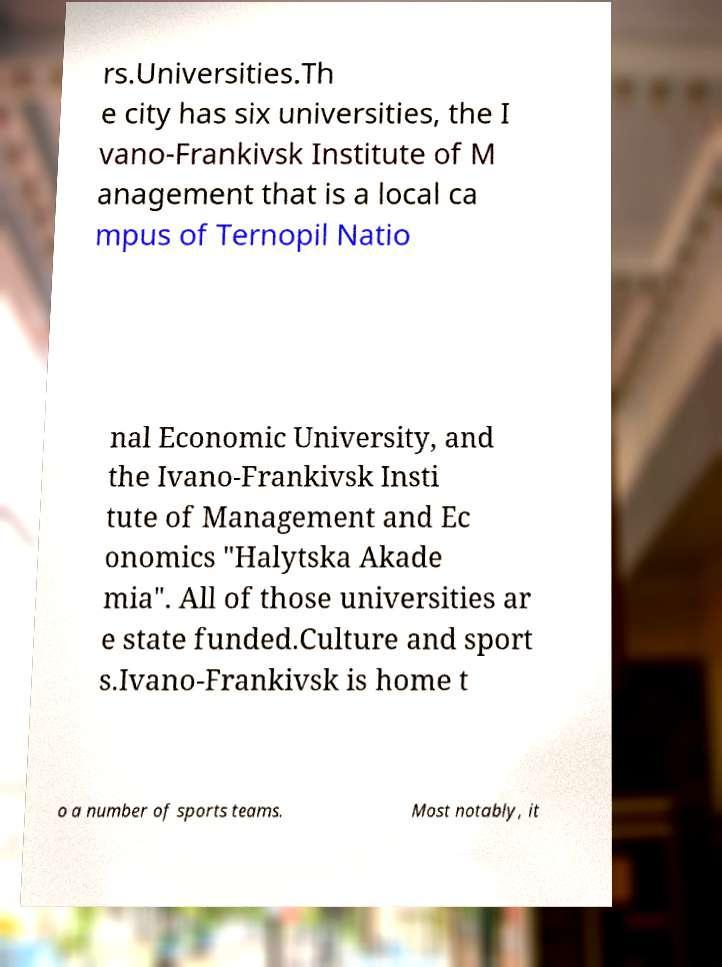Can you read and provide the text displayed in the image?This photo seems to have some interesting text. Can you extract and type it out for me? rs.Universities.Th e city has six universities, the I vano-Frankivsk Institute of M anagement that is a local ca mpus of Ternopil Natio nal Economic University, and the Ivano-Frankivsk Insti tute of Management and Ec onomics "Halytska Akade mia". All of those universities ar e state funded.Culture and sport s.Ivano-Frankivsk is home t o a number of sports teams. Most notably, it 